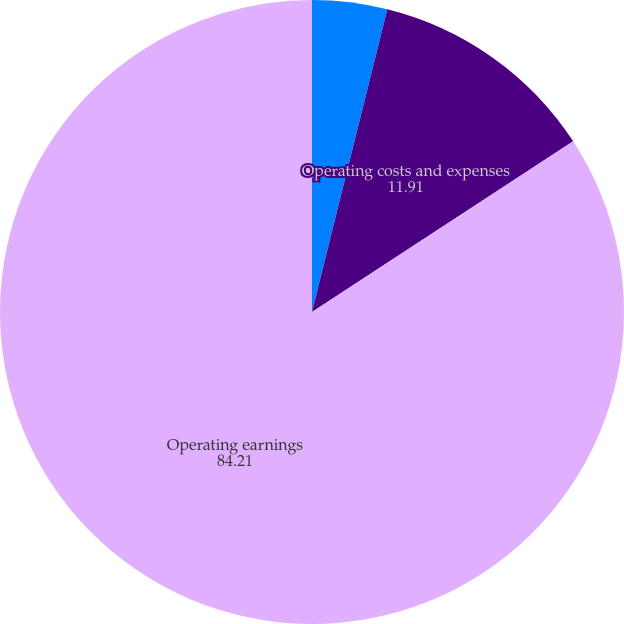Convert chart. <chart><loc_0><loc_0><loc_500><loc_500><pie_chart><fcel>Revenues<fcel>Operating costs and expenses<fcel>Operating earnings<nl><fcel>3.88%<fcel>11.91%<fcel>84.21%<nl></chart> 